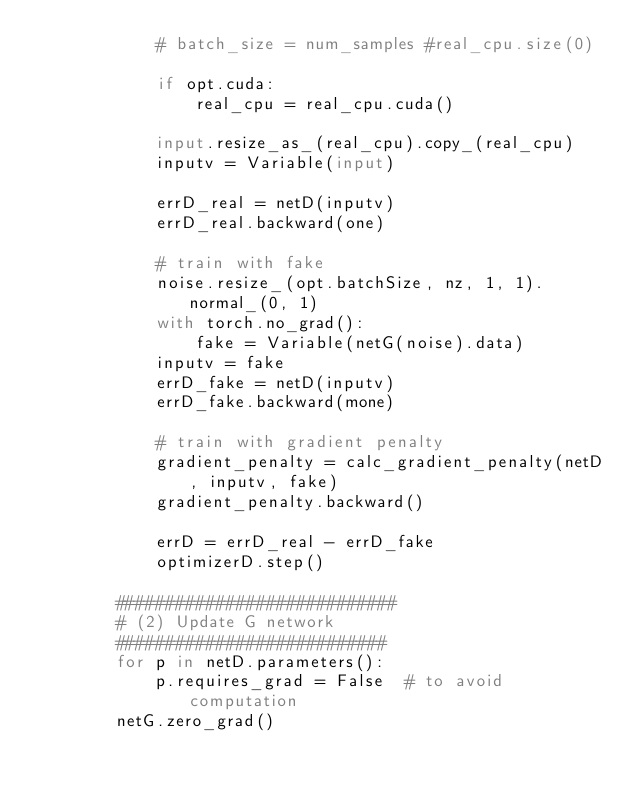<code> <loc_0><loc_0><loc_500><loc_500><_Python_>            # batch_size = num_samples #real_cpu.size(0)

            if opt.cuda:
                real_cpu = real_cpu.cuda()

            input.resize_as_(real_cpu).copy_(real_cpu)
            inputv = Variable(input)

            errD_real = netD(inputv)
            errD_real.backward(one)

            # train with fake
            noise.resize_(opt.batchSize, nz, 1, 1).normal_(0, 1)
            with torch.no_grad():
                fake = Variable(netG(noise).data)
            inputv = fake
            errD_fake = netD(inputv)
            errD_fake.backward(mone)

            # train with gradient penalty
            gradient_penalty = calc_gradient_penalty(netD, inputv, fake)
            gradient_penalty.backward()

            errD = errD_real - errD_fake
            optimizerD.step()

        ############################
        # (2) Update G network
        ###########################
        for p in netD.parameters():
            p.requires_grad = False  # to avoid computation
        netG.zero_grad()</code> 